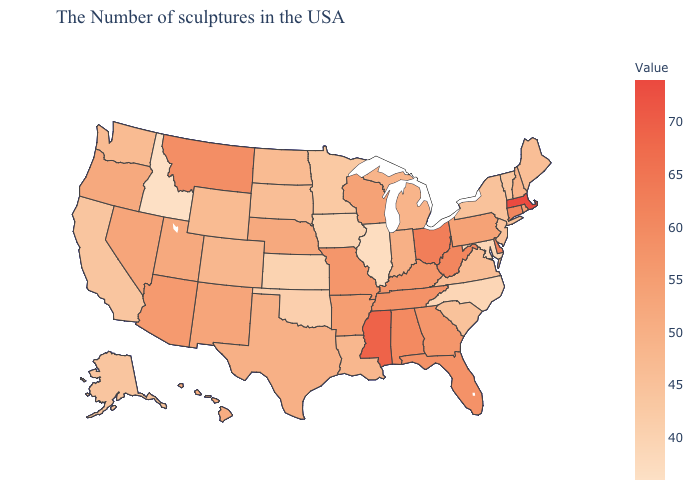Does South Dakota have a lower value than Maryland?
Concise answer only. No. Does Massachusetts have the highest value in the USA?
Give a very brief answer. Yes. Which states have the lowest value in the MidWest?
Keep it brief. Illinois. 